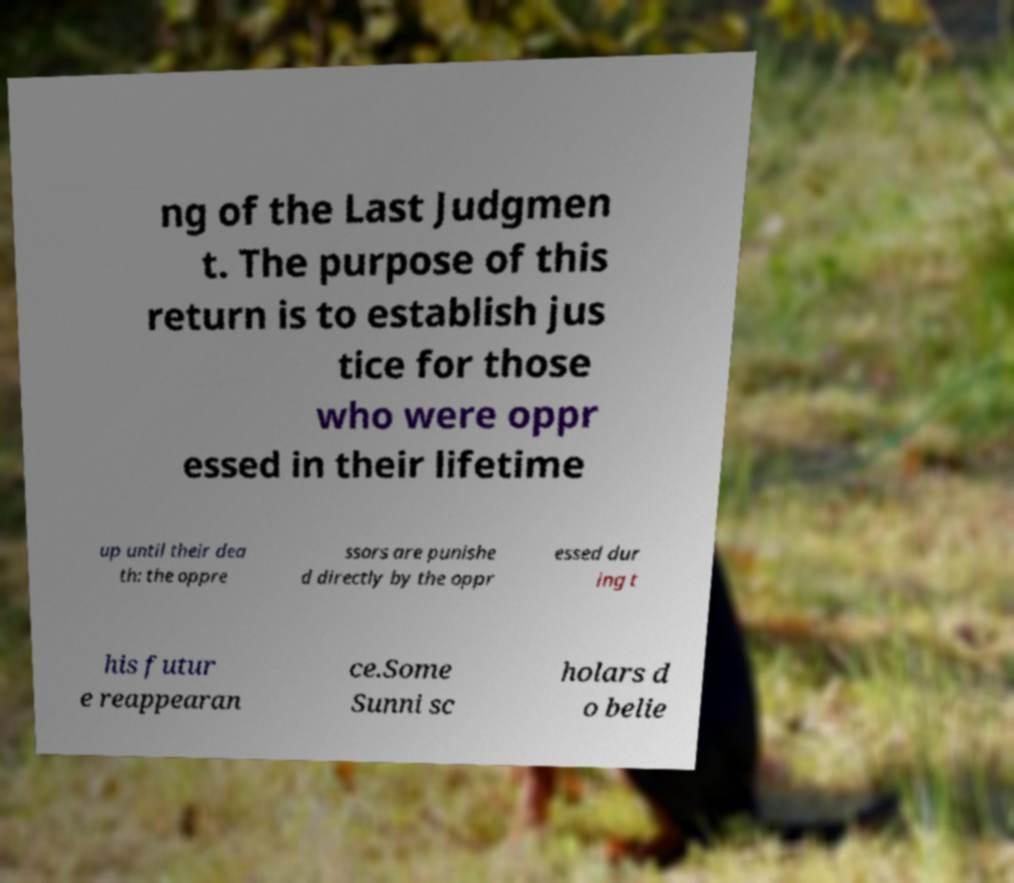Please identify and transcribe the text found in this image. ng of the Last Judgmen t. The purpose of this return is to establish jus tice for those who were oppr essed in their lifetime up until their dea th: the oppre ssors are punishe d directly by the oppr essed dur ing t his futur e reappearan ce.Some Sunni sc holars d o belie 